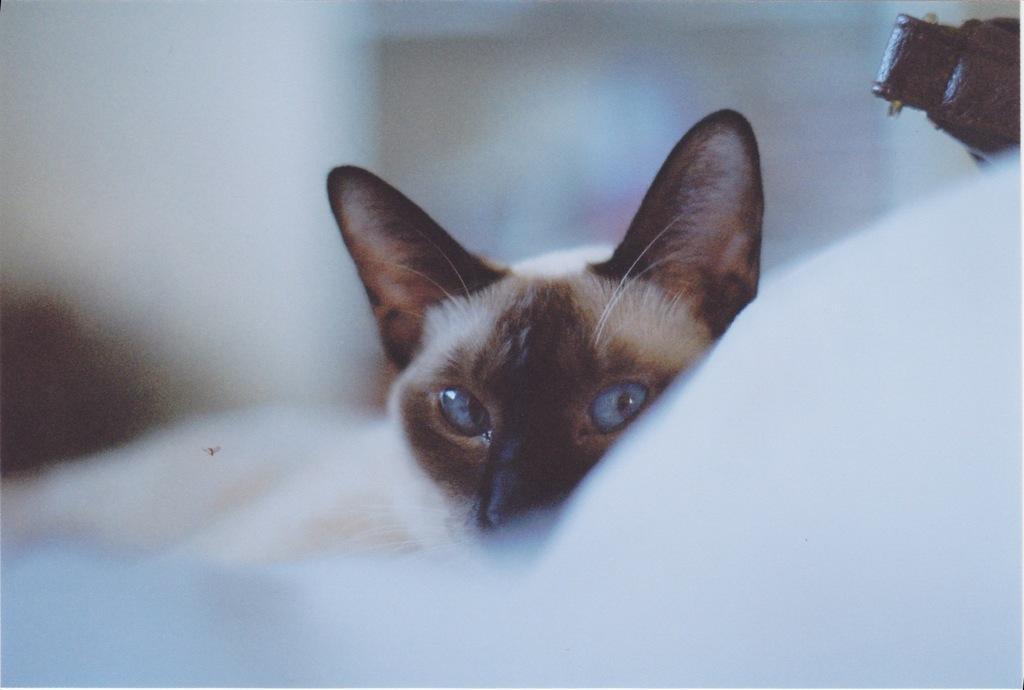Could you give a brief overview of what you see in this image? In this image we can see a cat. In the background it is blur. 